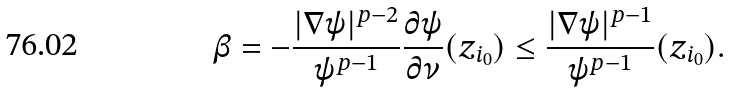<formula> <loc_0><loc_0><loc_500><loc_500>\beta = - \frac { | \nabla \psi | ^ { p - 2 } } { \psi ^ { p - 1 } } \frac { \partial \psi } { \partial \nu } ( z _ { i _ { 0 } } ) \leq \frac { | \nabla \psi | ^ { p - 1 } } { \psi ^ { p - 1 } } ( z _ { i _ { 0 } } ) .</formula> 